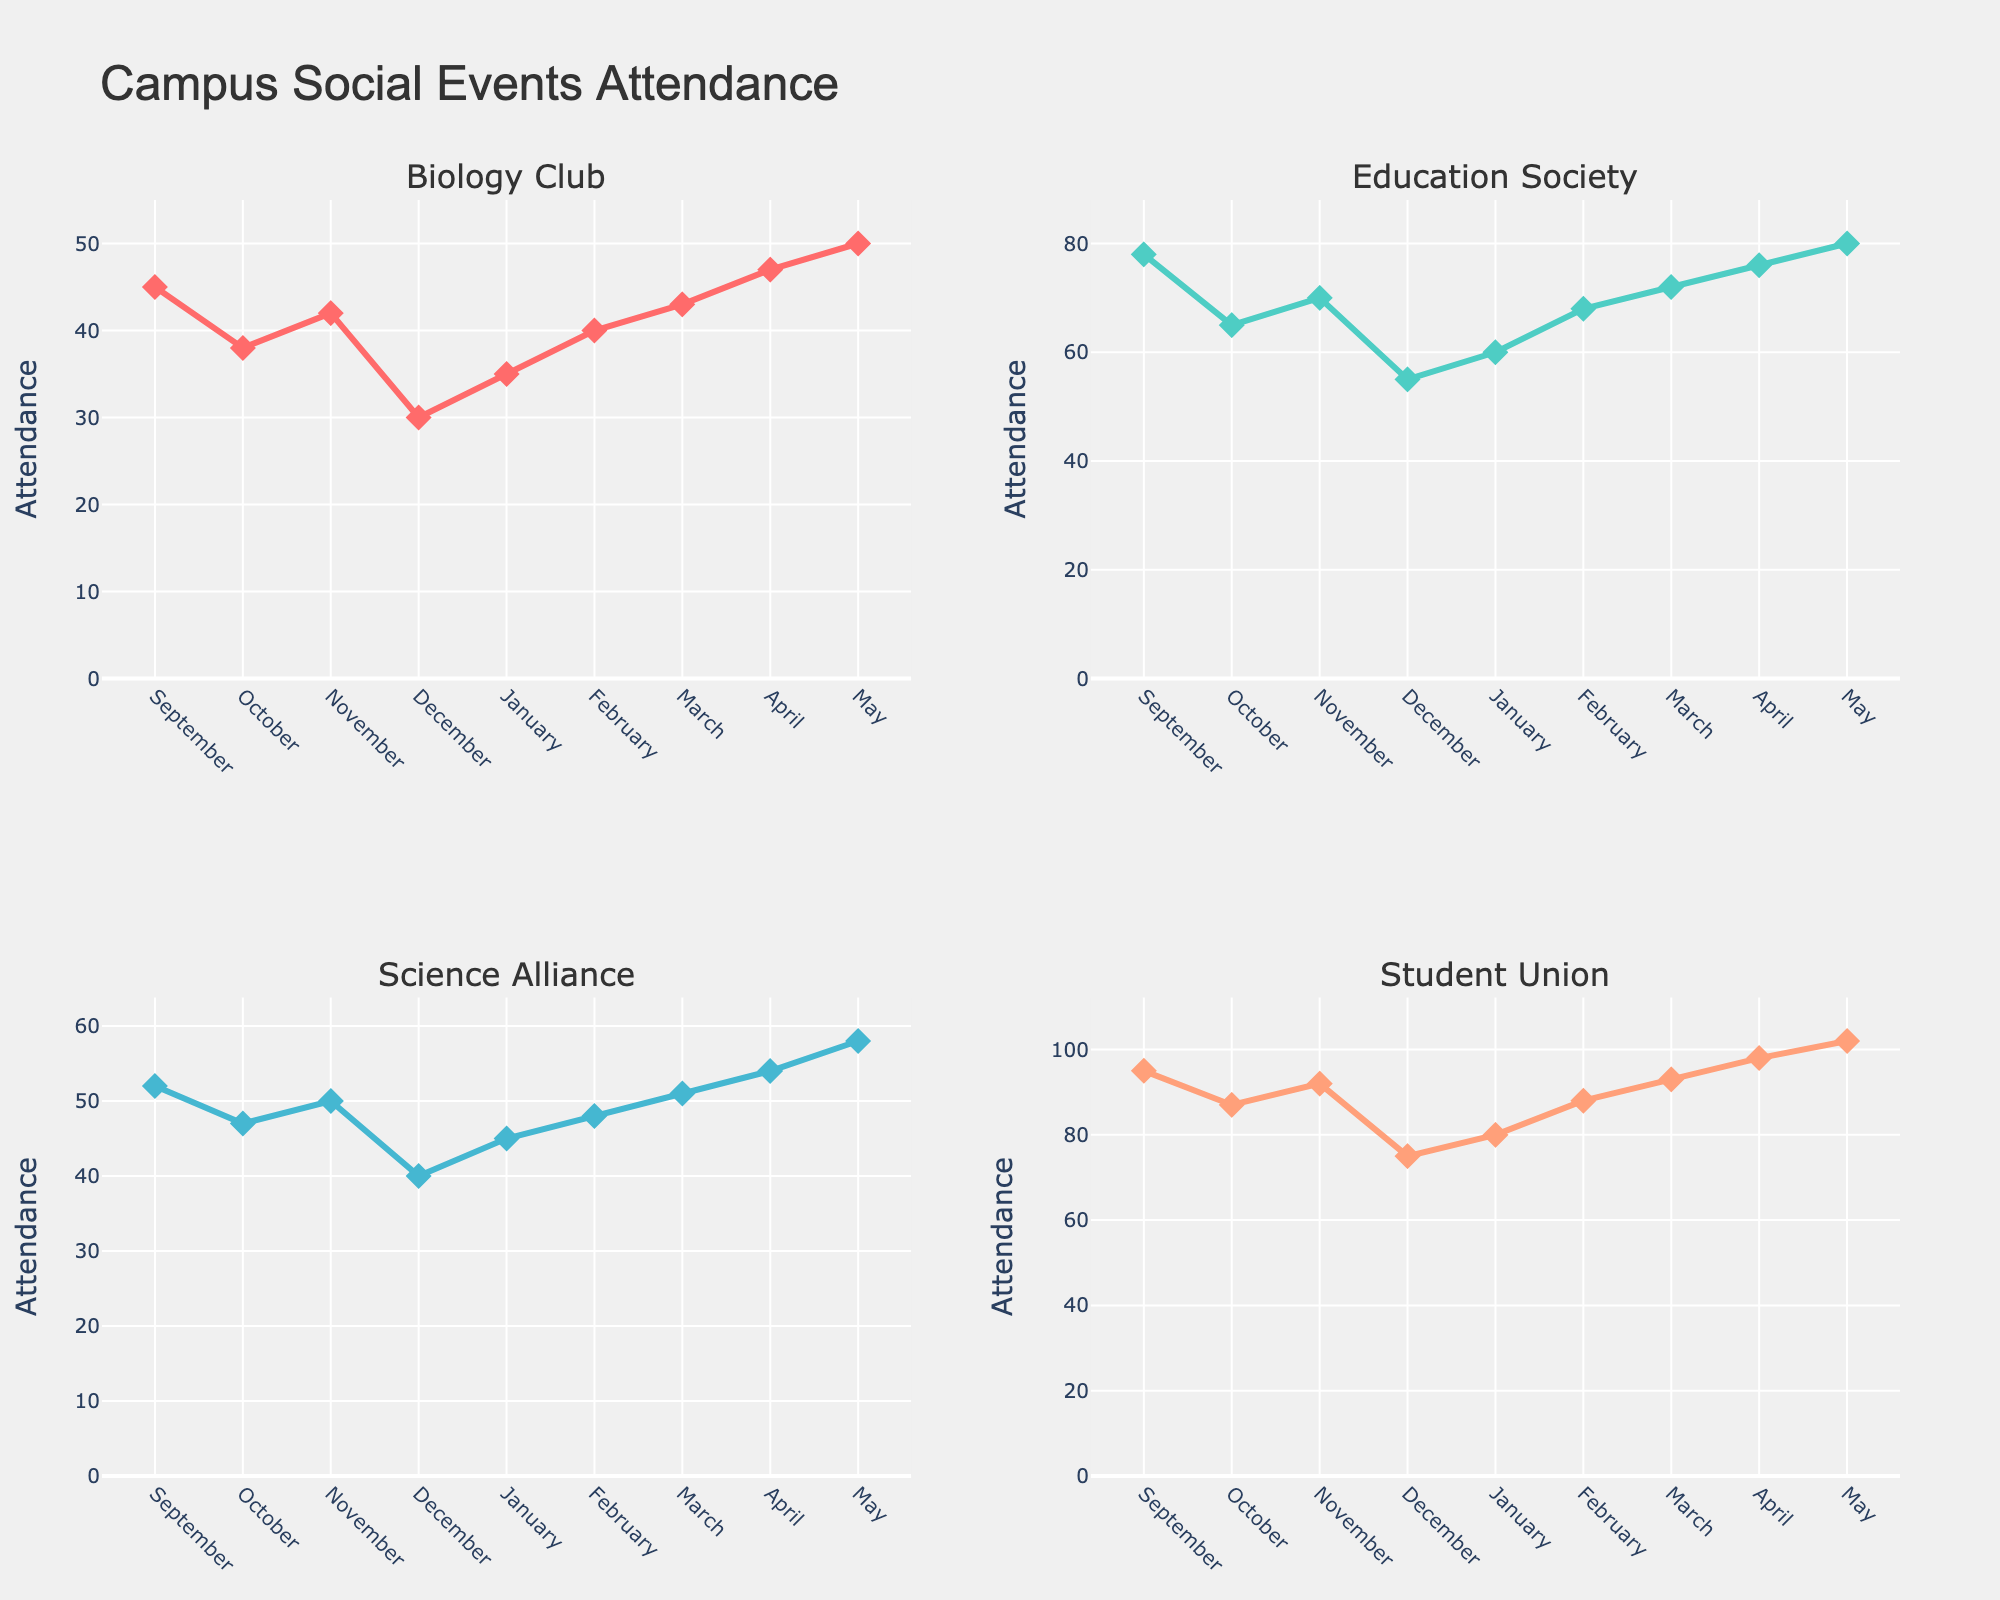What's the title of the figure? The title of the figure is displayed at the top and provides an overview of what the figure represents.
Answer: "Funding Allocation for Innovation Pipeline Stages in Fortune 500 Companies" What are the five stages of the innovation pipeline shown in the figure? The stages are listed on the x-axis of each subplot, each representing a phase in the innovation pipeline.
Answer: Ideation, Proof of Concept, Prototyping, Pilot Testing, Commercialization Which company allocates the highest percentage to Prototyping? To find this, look at the value for Prototyping (the third bar) in each subplot and identify the one with the highest value.
Answer: Boeing How much total funding does Apple allocate to Pilot Testing and Commercialization combined? Add the values for Pilot Testing and Commercialization for Apple from its subplot (18 for Pilot Testing and 15 for Commercialization).
Answer: 33 Compare Google's allocation to Proof of Concept and Ideation. Which stage receives more funding? Compare the heights of the bars for Proof of Concept and Ideation in Google's subplot. Proof of Concept has a higher value (28) compared to Ideation (20).
Answer: Proof of Concept Which company has the least funding allocated to Ideation? Compare the Ideation bar (first bar) across all subplots and identify the smallest value.
Answer: Boeing How does Intel's funding for Pilot Testing compare to Microsoft's? Look at the Pilot Testing bars (fourth bar) for both Intel and Microsoft. Intel has 22 while Microsoft has 25.
Answer: Intel's allocation is less than Microsoft's What is the average funding allocation for Commercialization across all companies? Add the values for Commercialization for all companies and divide by the number of companies (sum is 153, and there are 10 companies).
Answer: 15.3 Rank the companies by their funding allocation to Proof of Concept from highest to lowest. List the companies' allocations for Proof of Concept and order them: Google (28), Amazon (25), Apple (22), Intel (20), Microsoft (20), Pfizer (18), Johnson & Johnson (18), General Electric (15), Procter & Gamble (15), Boeing (12).
Answer: Google, Amazon, Apple, Microsoft & Intel, Johnson & Johnson & Pfizer, General Electric & Procter & Gamble, Boeing Which company has the most balanced funding distribution across all stages? A balanced distribution would have similar values across all stages. We need to visually inspect each company’s subplot and compare the variation of bar heights.
Answer: Apple 